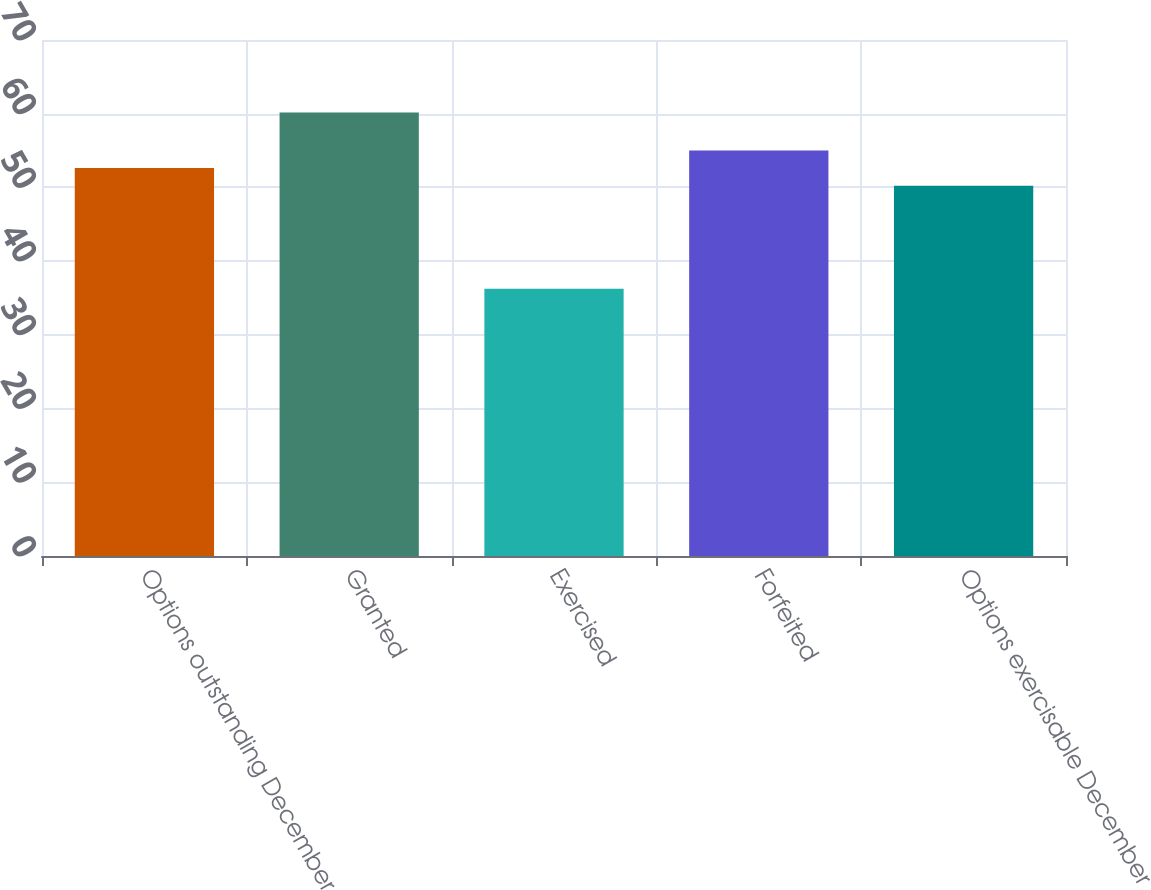<chart> <loc_0><loc_0><loc_500><loc_500><bar_chart><fcel>Options outstanding December<fcel>Granted<fcel>Exercised<fcel>Forfeited<fcel>Options exercisable December<nl><fcel>52.63<fcel>60.17<fcel>36.25<fcel>55.02<fcel>50.24<nl></chart> 